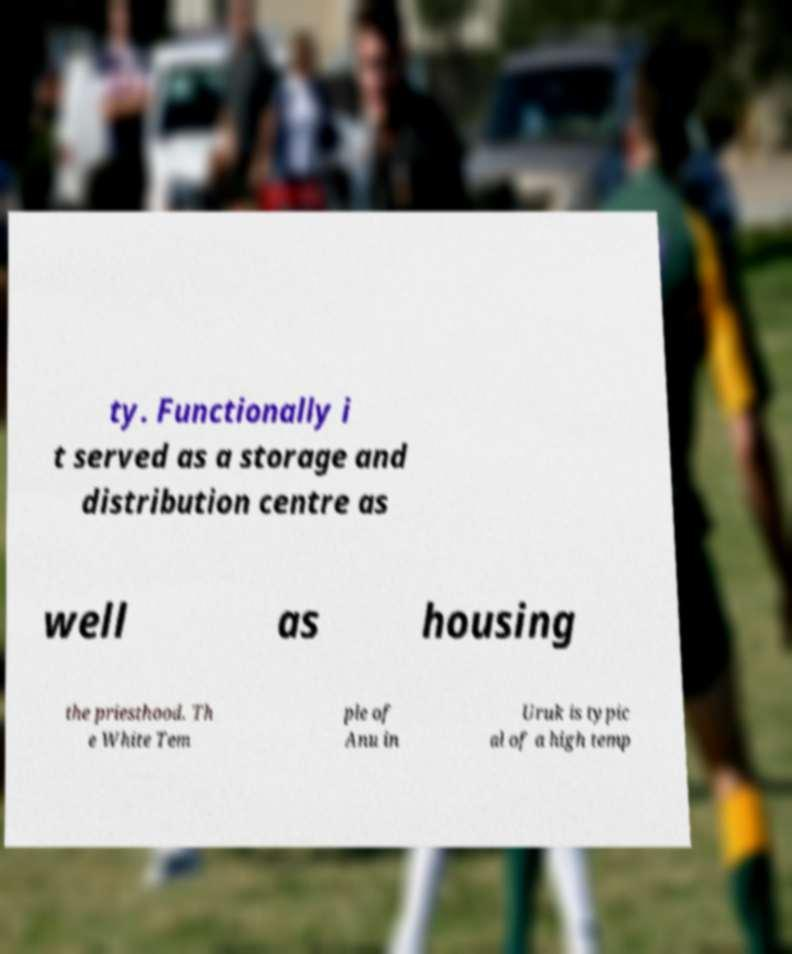Could you assist in decoding the text presented in this image and type it out clearly? ty. Functionally i t served as a storage and distribution centre as well as housing the priesthood. Th e White Tem ple of Anu in Uruk is typic al of a high temp 